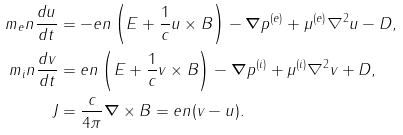Convert formula to latex. <formula><loc_0><loc_0><loc_500><loc_500>m _ { e } n \frac { d u } { d t } & = - e n \left ( E + \frac { 1 } { c } u \times B \right ) - \boldsymbol \nabla p ^ { ( e ) } + \mu ^ { ( e ) } \nabla ^ { 2 } u - D , \\ m _ { i } n \frac { d v } { d t } & = e n \left ( E + \frac { 1 } { c } v \times B \right ) - \boldsymbol \nabla p ^ { ( i ) } + \mu ^ { ( i ) } \nabla ^ { 2 } v + D , \\ J & = \frac { c } { 4 \pi } \boldsymbol \nabla \times B = { e n } ( v - u ) .</formula> 